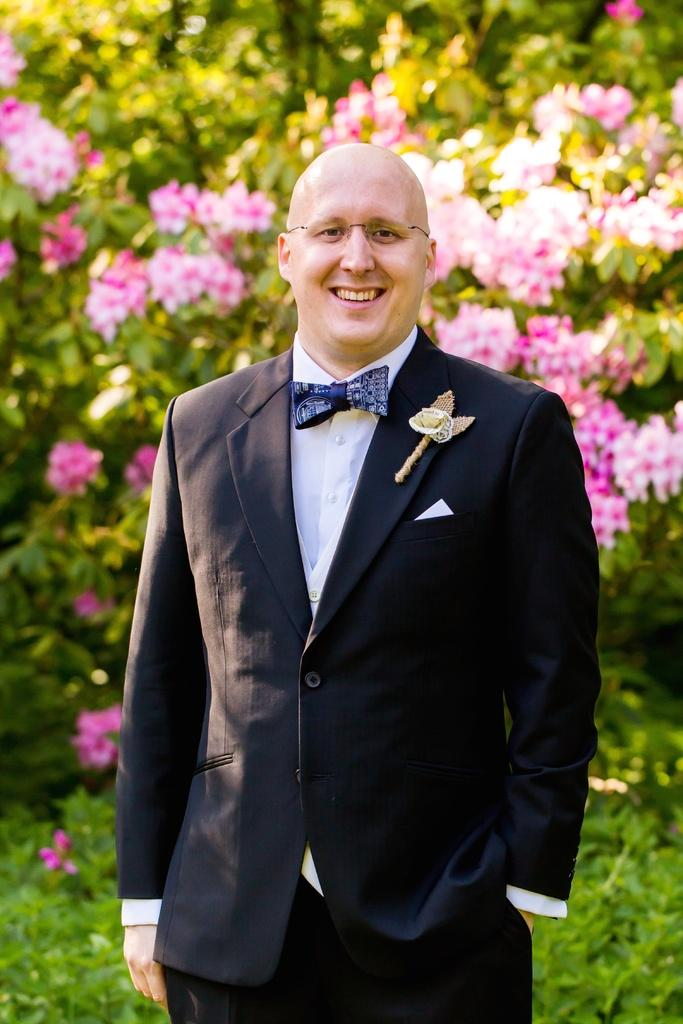What type of natural elements can be seen in the background of the image? There are flowers, trees, and plants in the background of the image. Can you describe the person in the image? There is a man in the image. What is the man wearing on his upper body? The man is wearing a blazer. Are there any accessories visible on the man? Yes, the man is wearing spectacles. What is the man's facial expression in the image? The man is smiling. What type of pets can be seen in the image? There are no pets visible in the image. What type of dress is the man wearing in the image? The man is not wearing a dress; he is wearing a blazer. 